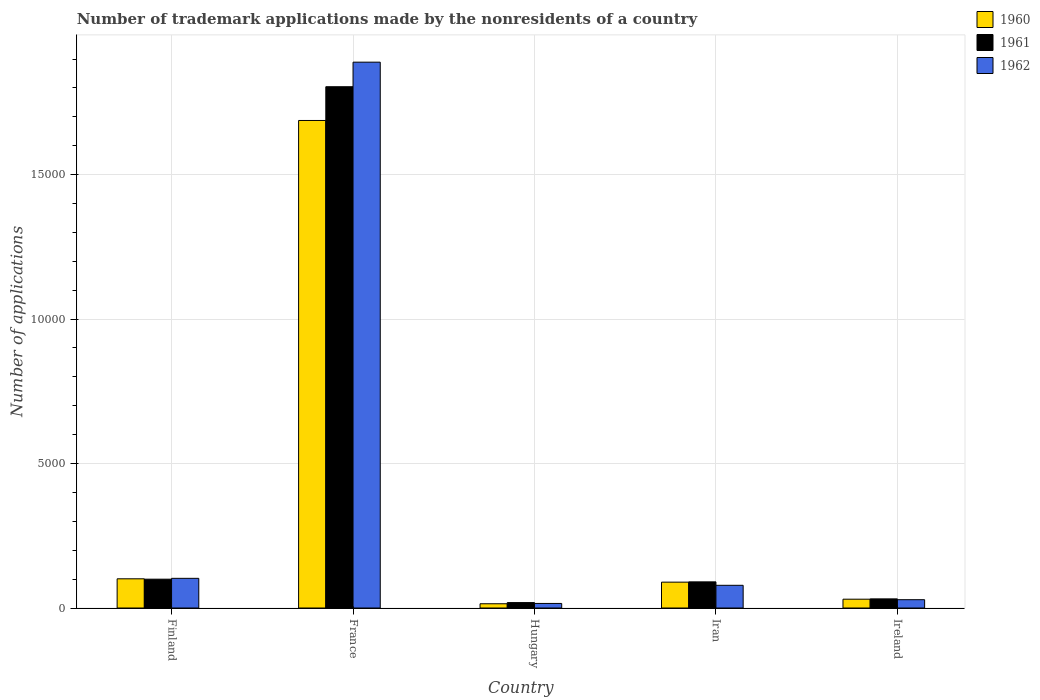Are the number of bars per tick equal to the number of legend labels?
Give a very brief answer. Yes. Are the number of bars on each tick of the X-axis equal?
Ensure brevity in your answer.  Yes. How many bars are there on the 3rd tick from the left?
Keep it short and to the point. 3. What is the label of the 1st group of bars from the left?
Give a very brief answer. Finland. In how many cases, is the number of bars for a given country not equal to the number of legend labels?
Provide a short and direct response. 0. What is the number of trademark applications made by the nonresidents in 1962 in Ireland?
Your response must be concise. 288. Across all countries, what is the maximum number of trademark applications made by the nonresidents in 1962?
Your response must be concise. 1.89e+04. Across all countries, what is the minimum number of trademark applications made by the nonresidents in 1961?
Keep it short and to the point. 188. In which country was the number of trademark applications made by the nonresidents in 1962 minimum?
Your answer should be very brief. Hungary. What is the total number of trademark applications made by the nonresidents in 1961 in the graph?
Make the answer very short. 2.04e+04. What is the difference between the number of trademark applications made by the nonresidents in 1960 in Finland and that in Hungary?
Give a very brief answer. 864. What is the difference between the number of trademark applications made by the nonresidents in 1960 in France and the number of trademark applications made by the nonresidents in 1962 in Finland?
Offer a terse response. 1.58e+04. What is the average number of trademark applications made by the nonresidents in 1962 per country?
Keep it short and to the point. 4230.2. What is the ratio of the number of trademark applications made by the nonresidents in 1960 in France to that in Iran?
Your answer should be compact. 18.85. What is the difference between the highest and the second highest number of trademark applications made by the nonresidents in 1960?
Your answer should be compact. 1.59e+04. What is the difference between the highest and the lowest number of trademark applications made by the nonresidents in 1962?
Offer a terse response. 1.87e+04. What does the 1st bar from the left in Finland represents?
Provide a short and direct response. 1960. What does the 3rd bar from the right in Finland represents?
Offer a terse response. 1960. Is it the case that in every country, the sum of the number of trademark applications made by the nonresidents in 1961 and number of trademark applications made by the nonresidents in 1962 is greater than the number of trademark applications made by the nonresidents in 1960?
Offer a terse response. Yes. How many countries are there in the graph?
Your response must be concise. 5. What is the difference between two consecutive major ticks on the Y-axis?
Make the answer very short. 5000. How many legend labels are there?
Offer a very short reply. 3. What is the title of the graph?
Offer a terse response. Number of trademark applications made by the nonresidents of a country. What is the label or title of the X-axis?
Your response must be concise. Country. What is the label or title of the Y-axis?
Give a very brief answer. Number of applications. What is the Number of applications of 1960 in Finland?
Give a very brief answer. 1011. What is the Number of applications in 1961 in Finland?
Keep it short and to the point. 998. What is the Number of applications in 1962 in Finland?
Your response must be concise. 1027. What is the Number of applications in 1960 in France?
Your response must be concise. 1.69e+04. What is the Number of applications in 1961 in France?
Your answer should be very brief. 1.80e+04. What is the Number of applications in 1962 in France?
Ensure brevity in your answer.  1.89e+04. What is the Number of applications in 1960 in Hungary?
Make the answer very short. 147. What is the Number of applications of 1961 in Hungary?
Give a very brief answer. 188. What is the Number of applications in 1962 in Hungary?
Offer a very short reply. 158. What is the Number of applications of 1960 in Iran?
Provide a succinct answer. 895. What is the Number of applications in 1961 in Iran?
Keep it short and to the point. 905. What is the Number of applications in 1962 in Iran?
Your response must be concise. 786. What is the Number of applications in 1960 in Ireland?
Provide a succinct answer. 305. What is the Number of applications in 1961 in Ireland?
Offer a terse response. 316. What is the Number of applications of 1962 in Ireland?
Keep it short and to the point. 288. Across all countries, what is the maximum Number of applications of 1960?
Ensure brevity in your answer.  1.69e+04. Across all countries, what is the maximum Number of applications in 1961?
Provide a succinct answer. 1.80e+04. Across all countries, what is the maximum Number of applications in 1962?
Your answer should be very brief. 1.89e+04. Across all countries, what is the minimum Number of applications of 1960?
Offer a very short reply. 147. Across all countries, what is the minimum Number of applications of 1961?
Ensure brevity in your answer.  188. Across all countries, what is the minimum Number of applications in 1962?
Keep it short and to the point. 158. What is the total Number of applications of 1960 in the graph?
Keep it short and to the point. 1.92e+04. What is the total Number of applications in 1961 in the graph?
Keep it short and to the point. 2.04e+04. What is the total Number of applications in 1962 in the graph?
Keep it short and to the point. 2.12e+04. What is the difference between the Number of applications in 1960 in Finland and that in France?
Offer a terse response. -1.59e+04. What is the difference between the Number of applications of 1961 in Finland and that in France?
Keep it short and to the point. -1.70e+04. What is the difference between the Number of applications of 1962 in Finland and that in France?
Keep it short and to the point. -1.79e+04. What is the difference between the Number of applications in 1960 in Finland and that in Hungary?
Make the answer very short. 864. What is the difference between the Number of applications in 1961 in Finland and that in Hungary?
Keep it short and to the point. 810. What is the difference between the Number of applications of 1962 in Finland and that in Hungary?
Provide a short and direct response. 869. What is the difference between the Number of applications of 1960 in Finland and that in Iran?
Offer a terse response. 116. What is the difference between the Number of applications in 1961 in Finland and that in Iran?
Offer a terse response. 93. What is the difference between the Number of applications in 1962 in Finland and that in Iran?
Make the answer very short. 241. What is the difference between the Number of applications in 1960 in Finland and that in Ireland?
Offer a terse response. 706. What is the difference between the Number of applications in 1961 in Finland and that in Ireland?
Offer a very short reply. 682. What is the difference between the Number of applications in 1962 in Finland and that in Ireland?
Offer a terse response. 739. What is the difference between the Number of applications of 1960 in France and that in Hungary?
Ensure brevity in your answer.  1.67e+04. What is the difference between the Number of applications in 1961 in France and that in Hungary?
Provide a succinct answer. 1.79e+04. What is the difference between the Number of applications of 1962 in France and that in Hungary?
Ensure brevity in your answer.  1.87e+04. What is the difference between the Number of applications of 1960 in France and that in Iran?
Keep it short and to the point. 1.60e+04. What is the difference between the Number of applications of 1961 in France and that in Iran?
Provide a succinct answer. 1.71e+04. What is the difference between the Number of applications in 1962 in France and that in Iran?
Your response must be concise. 1.81e+04. What is the difference between the Number of applications in 1960 in France and that in Ireland?
Give a very brief answer. 1.66e+04. What is the difference between the Number of applications of 1961 in France and that in Ireland?
Keep it short and to the point. 1.77e+04. What is the difference between the Number of applications in 1962 in France and that in Ireland?
Your response must be concise. 1.86e+04. What is the difference between the Number of applications in 1960 in Hungary and that in Iran?
Offer a very short reply. -748. What is the difference between the Number of applications in 1961 in Hungary and that in Iran?
Provide a succinct answer. -717. What is the difference between the Number of applications of 1962 in Hungary and that in Iran?
Provide a succinct answer. -628. What is the difference between the Number of applications in 1960 in Hungary and that in Ireland?
Ensure brevity in your answer.  -158. What is the difference between the Number of applications in 1961 in Hungary and that in Ireland?
Offer a very short reply. -128. What is the difference between the Number of applications in 1962 in Hungary and that in Ireland?
Make the answer very short. -130. What is the difference between the Number of applications of 1960 in Iran and that in Ireland?
Keep it short and to the point. 590. What is the difference between the Number of applications in 1961 in Iran and that in Ireland?
Give a very brief answer. 589. What is the difference between the Number of applications in 1962 in Iran and that in Ireland?
Keep it short and to the point. 498. What is the difference between the Number of applications of 1960 in Finland and the Number of applications of 1961 in France?
Offer a terse response. -1.70e+04. What is the difference between the Number of applications of 1960 in Finland and the Number of applications of 1962 in France?
Offer a very short reply. -1.79e+04. What is the difference between the Number of applications in 1961 in Finland and the Number of applications in 1962 in France?
Offer a terse response. -1.79e+04. What is the difference between the Number of applications in 1960 in Finland and the Number of applications in 1961 in Hungary?
Offer a very short reply. 823. What is the difference between the Number of applications of 1960 in Finland and the Number of applications of 1962 in Hungary?
Your answer should be compact. 853. What is the difference between the Number of applications in 1961 in Finland and the Number of applications in 1962 in Hungary?
Your answer should be compact. 840. What is the difference between the Number of applications of 1960 in Finland and the Number of applications of 1961 in Iran?
Offer a terse response. 106. What is the difference between the Number of applications in 1960 in Finland and the Number of applications in 1962 in Iran?
Your answer should be compact. 225. What is the difference between the Number of applications of 1961 in Finland and the Number of applications of 1962 in Iran?
Give a very brief answer. 212. What is the difference between the Number of applications of 1960 in Finland and the Number of applications of 1961 in Ireland?
Ensure brevity in your answer.  695. What is the difference between the Number of applications of 1960 in Finland and the Number of applications of 1962 in Ireland?
Keep it short and to the point. 723. What is the difference between the Number of applications of 1961 in Finland and the Number of applications of 1962 in Ireland?
Offer a terse response. 710. What is the difference between the Number of applications of 1960 in France and the Number of applications of 1961 in Hungary?
Your response must be concise. 1.67e+04. What is the difference between the Number of applications in 1960 in France and the Number of applications in 1962 in Hungary?
Make the answer very short. 1.67e+04. What is the difference between the Number of applications of 1961 in France and the Number of applications of 1962 in Hungary?
Give a very brief answer. 1.79e+04. What is the difference between the Number of applications in 1960 in France and the Number of applications in 1961 in Iran?
Your answer should be compact. 1.60e+04. What is the difference between the Number of applications of 1960 in France and the Number of applications of 1962 in Iran?
Offer a very short reply. 1.61e+04. What is the difference between the Number of applications in 1961 in France and the Number of applications in 1962 in Iran?
Offer a very short reply. 1.73e+04. What is the difference between the Number of applications in 1960 in France and the Number of applications in 1961 in Ireland?
Make the answer very short. 1.66e+04. What is the difference between the Number of applications in 1960 in France and the Number of applications in 1962 in Ireland?
Your answer should be very brief. 1.66e+04. What is the difference between the Number of applications of 1961 in France and the Number of applications of 1962 in Ireland?
Provide a succinct answer. 1.78e+04. What is the difference between the Number of applications of 1960 in Hungary and the Number of applications of 1961 in Iran?
Make the answer very short. -758. What is the difference between the Number of applications in 1960 in Hungary and the Number of applications in 1962 in Iran?
Your answer should be very brief. -639. What is the difference between the Number of applications of 1961 in Hungary and the Number of applications of 1962 in Iran?
Give a very brief answer. -598. What is the difference between the Number of applications in 1960 in Hungary and the Number of applications in 1961 in Ireland?
Offer a terse response. -169. What is the difference between the Number of applications of 1960 in Hungary and the Number of applications of 1962 in Ireland?
Your answer should be very brief. -141. What is the difference between the Number of applications in 1961 in Hungary and the Number of applications in 1962 in Ireland?
Your response must be concise. -100. What is the difference between the Number of applications in 1960 in Iran and the Number of applications in 1961 in Ireland?
Offer a terse response. 579. What is the difference between the Number of applications of 1960 in Iran and the Number of applications of 1962 in Ireland?
Provide a short and direct response. 607. What is the difference between the Number of applications of 1961 in Iran and the Number of applications of 1962 in Ireland?
Make the answer very short. 617. What is the average Number of applications in 1960 per country?
Keep it short and to the point. 3846.4. What is the average Number of applications in 1961 per country?
Offer a terse response. 4089.8. What is the average Number of applications of 1962 per country?
Your response must be concise. 4230.2. What is the difference between the Number of applications of 1960 and Number of applications of 1962 in Finland?
Ensure brevity in your answer.  -16. What is the difference between the Number of applications in 1961 and Number of applications in 1962 in Finland?
Offer a very short reply. -29. What is the difference between the Number of applications in 1960 and Number of applications in 1961 in France?
Your answer should be very brief. -1168. What is the difference between the Number of applications in 1960 and Number of applications in 1962 in France?
Ensure brevity in your answer.  -2018. What is the difference between the Number of applications of 1961 and Number of applications of 1962 in France?
Make the answer very short. -850. What is the difference between the Number of applications in 1960 and Number of applications in 1961 in Hungary?
Keep it short and to the point. -41. What is the difference between the Number of applications of 1961 and Number of applications of 1962 in Hungary?
Make the answer very short. 30. What is the difference between the Number of applications of 1960 and Number of applications of 1962 in Iran?
Ensure brevity in your answer.  109. What is the difference between the Number of applications in 1961 and Number of applications in 1962 in Iran?
Make the answer very short. 119. What is the ratio of the Number of applications of 1960 in Finland to that in France?
Offer a very short reply. 0.06. What is the ratio of the Number of applications of 1961 in Finland to that in France?
Provide a short and direct response. 0.06. What is the ratio of the Number of applications in 1962 in Finland to that in France?
Your answer should be compact. 0.05. What is the ratio of the Number of applications of 1960 in Finland to that in Hungary?
Provide a short and direct response. 6.88. What is the ratio of the Number of applications in 1961 in Finland to that in Hungary?
Ensure brevity in your answer.  5.31. What is the ratio of the Number of applications in 1960 in Finland to that in Iran?
Your answer should be very brief. 1.13. What is the ratio of the Number of applications of 1961 in Finland to that in Iran?
Make the answer very short. 1.1. What is the ratio of the Number of applications in 1962 in Finland to that in Iran?
Give a very brief answer. 1.31. What is the ratio of the Number of applications in 1960 in Finland to that in Ireland?
Keep it short and to the point. 3.31. What is the ratio of the Number of applications of 1961 in Finland to that in Ireland?
Your answer should be compact. 3.16. What is the ratio of the Number of applications of 1962 in Finland to that in Ireland?
Your answer should be very brief. 3.57. What is the ratio of the Number of applications in 1960 in France to that in Hungary?
Offer a terse response. 114.79. What is the ratio of the Number of applications in 1961 in France to that in Hungary?
Provide a short and direct response. 95.97. What is the ratio of the Number of applications in 1962 in France to that in Hungary?
Provide a short and direct response. 119.57. What is the ratio of the Number of applications of 1960 in France to that in Iran?
Offer a terse response. 18.85. What is the ratio of the Number of applications of 1961 in France to that in Iran?
Give a very brief answer. 19.94. What is the ratio of the Number of applications of 1962 in France to that in Iran?
Offer a terse response. 24.04. What is the ratio of the Number of applications in 1960 in France to that in Ireland?
Make the answer very short. 55.32. What is the ratio of the Number of applications in 1961 in France to that in Ireland?
Offer a terse response. 57.09. What is the ratio of the Number of applications in 1962 in France to that in Ireland?
Provide a succinct answer. 65.6. What is the ratio of the Number of applications in 1960 in Hungary to that in Iran?
Your response must be concise. 0.16. What is the ratio of the Number of applications of 1961 in Hungary to that in Iran?
Your response must be concise. 0.21. What is the ratio of the Number of applications of 1962 in Hungary to that in Iran?
Keep it short and to the point. 0.2. What is the ratio of the Number of applications in 1960 in Hungary to that in Ireland?
Offer a very short reply. 0.48. What is the ratio of the Number of applications of 1961 in Hungary to that in Ireland?
Provide a succinct answer. 0.59. What is the ratio of the Number of applications in 1962 in Hungary to that in Ireland?
Keep it short and to the point. 0.55. What is the ratio of the Number of applications in 1960 in Iran to that in Ireland?
Make the answer very short. 2.93. What is the ratio of the Number of applications of 1961 in Iran to that in Ireland?
Your answer should be very brief. 2.86. What is the ratio of the Number of applications of 1962 in Iran to that in Ireland?
Ensure brevity in your answer.  2.73. What is the difference between the highest and the second highest Number of applications in 1960?
Your answer should be very brief. 1.59e+04. What is the difference between the highest and the second highest Number of applications of 1961?
Provide a succinct answer. 1.70e+04. What is the difference between the highest and the second highest Number of applications of 1962?
Provide a short and direct response. 1.79e+04. What is the difference between the highest and the lowest Number of applications in 1960?
Provide a short and direct response. 1.67e+04. What is the difference between the highest and the lowest Number of applications in 1961?
Keep it short and to the point. 1.79e+04. What is the difference between the highest and the lowest Number of applications of 1962?
Provide a succinct answer. 1.87e+04. 